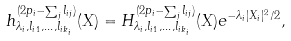Convert formula to latex. <formula><loc_0><loc_0><loc_500><loc_500>h _ { \lambda _ { i } , l _ { i 1 } , \dots , l _ { i k _ { i } } } ^ { ( 2 p _ { i } - \sum _ { j } l _ { i j } ) } ( X ) = H ^ { ( 2 p _ { i } - \sum _ { j } l _ { i j } ) } _ { \lambda _ { i } , l _ { i 1 } , \dots , l _ { i k _ { i } } } ( X ) e ^ { - \lambda _ { i } | X _ { i } | ^ { 2 } / 2 } ,</formula> 